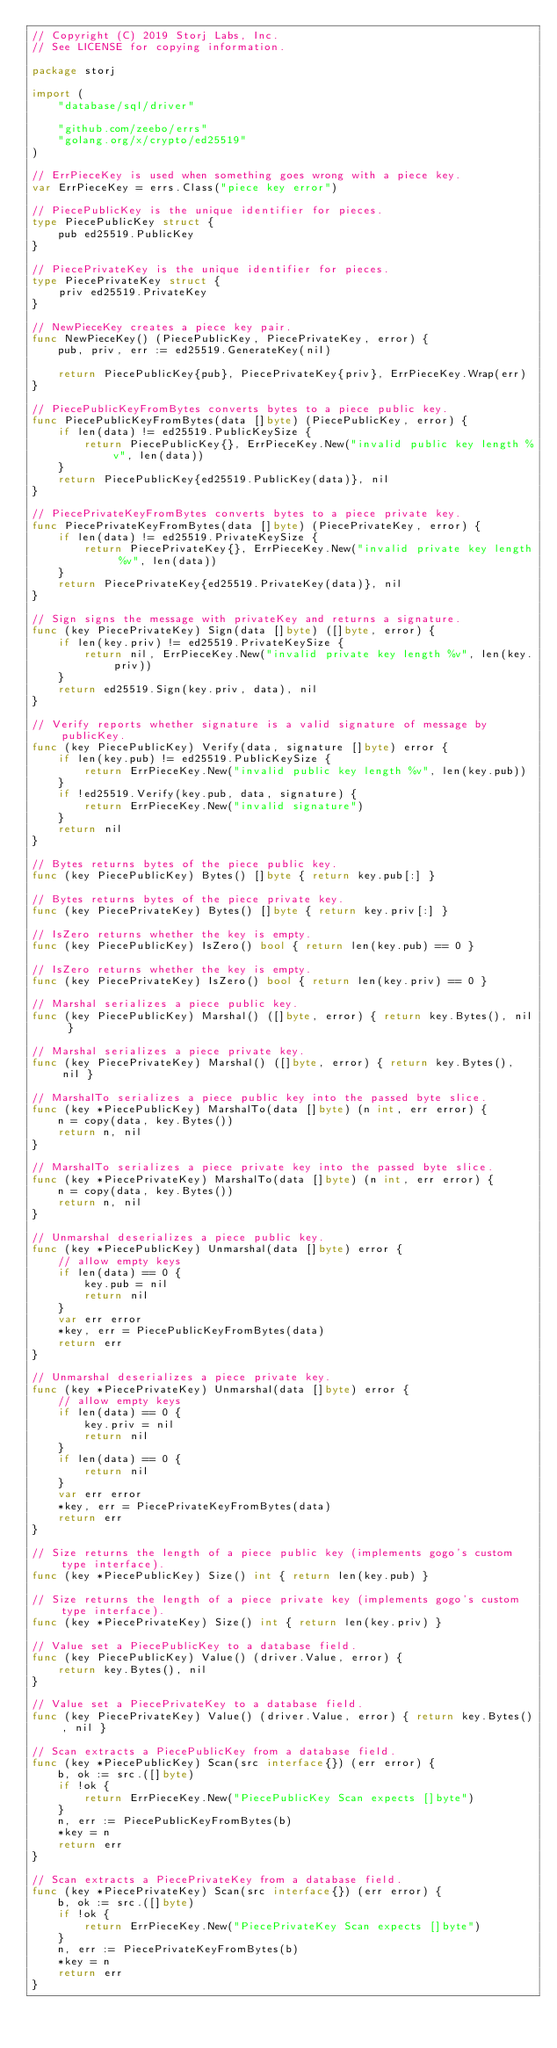Convert code to text. <code><loc_0><loc_0><loc_500><loc_500><_Go_>// Copyright (C) 2019 Storj Labs, Inc.
// See LICENSE for copying information.

package storj

import (
	"database/sql/driver"

	"github.com/zeebo/errs"
	"golang.org/x/crypto/ed25519"
)

// ErrPieceKey is used when something goes wrong with a piece key.
var ErrPieceKey = errs.Class("piece key error")

// PiecePublicKey is the unique identifier for pieces.
type PiecePublicKey struct {
	pub ed25519.PublicKey
}

// PiecePrivateKey is the unique identifier for pieces.
type PiecePrivateKey struct {
	priv ed25519.PrivateKey
}

// NewPieceKey creates a piece key pair.
func NewPieceKey() (PiecePublicKey, PiecePrivateKey, error) {
	pub, priv, err := ed25519.GenerateKey(nil)

	return PiecePublicKey{pub}, PiecePrivateKey{priv}, ErrPieceKey.Wrap(err)
}

// PiecePublicKeyFromBytes converts bytes to a piece public key.
func PiecePublicKeyFromBytes(data []byte) (PiecePublicKey, error) {
	if len(data) != ed25519.PublicKeySize {
		return PiecePublicKey{}, ErrPieceKey.New("invalid public key length %v", len(data))
	}
	return PiecePublicKey{ed25519.PublicKey(data)}, nil
}

// PiecePrivateKeyFromBytes converts bytes to a piece private key.
func PiecePrivateKeyFromBytes(data []byte) (PiecePrivateKey, error) {
	if len(data) != ed25519.PrivateKeySize {
		return PiecePrivateKey{}, ErrPieceKey.New("invalid private key length %v", len(data))
	}
	return PiecePrivateKey{ed25519.PrivateKey(data)}, nil
}

// Sign signs the message with privateKey and returns a signature.
func (key PiecePrivateKey) Sign(data []byte) ([]byte, error) {
	if len(key.priv) != ed25519.PrivateKeySize {
		return nil, ErrPieceKey.New("invalid private key length %v", len(key.priv))
	}
	return ed25519.Sign(key.priv, data), nil
}

// Verify reports whether signature is a valid signature of message by publicKey.
func (key PiecePublicKey) Verify(data, signature []byte) error {
	if len(key.pub) != ed25519.PublicKeySize {
		return ErrPieceKey.New("invalid public key length %v", len(key.pub))
	}
	if !ed25519.Verify(key.pub, data, signature) {
		return ErrPieceKey.New("invalid signature")
	}
	return nil
}

// Bytes returns bytes of the piece public key.
func (key PiecePublicKey) Bytes() []byte { return key.pub[:] }

// Bytes returns bytes of the piece private key.
func (key PiecePrivateKey) Bytes() []byte { return key.priv[:] }

// IsZero returns whether the key is empty.
func (key PiecePublicKey) IsZero() bool { return len(key.pub) == 0 }

// IsZero returns whether the key is empty.
func (key PiecePrivateKey) IsZero() bool { return len(key.priv) == 0 }

// Marshal serializes a piece public key.
func (key PiecePublicKey) Marshal() ([]byte, error) { return key.Bytes(), nil }

// Marshal serializes a piece private key.
func (key PiecePrivateKey) Marshal() ([]byte, error) { return key.Bytes(), nil }

// MarshalTo serializes a piece public key into the passed byte slice.
func (key *PiecePublicKey) MarshalTo(data []byte) (n int, err error) {
	n = copy(data, key.Bytes())
	return n, nil
}

// MarshalTo serializes a piece private key into the passed byte slice.
func (key *PiecePrivateKey) MarshalTo(data []byte) (n int, err error) {
	n = copy(data, key.Bytes())
	return n, nil
}

// Unmarshal deserializes a piece public key.
func (key *PiecePublicKey) Unmarshal(data []byte) error {
	// allow empty keys
	if len(data) == 0 {
		key.pub = nil
		return nil
	}
	var err error
	*key, err = PiecePublicKeyFromBytes(data)
	return err
}

// Unmarshal deserializes a piece private key.
func (key *PiecePrivateKey) Unmarshal(data []byte) error {
	// allow empty keys
	if len(data) == 0 {
		key.priv = nil
		return nil
	}
	if len(data) == 0 {
		return nil
	}
	var err error
	*key, err = PiecePrivateKeyFromBytes(data)
	return err
}

// Size returns the length of a piece public key (implements gogo's custom type interface).
func (key *PiecePublicKey) Size() int { return len(key.pub) }

// Size returns the length of a piece private key (implements gogo's custom type interface).
func (key *PiecePrivateKey) Size() int { return len(key.priv) }

// Value set a PiecePublicKey to a database field.
func (key PiecePublicKey) Value() (driver.Value, error) {
	return key.Bytes(), nil
}

// Value set a PiecePrivateKey to a database field.
func (key PiecePrivateKey) Value() (driver.Value, error) { return key.Bytes(), nil }

// Scan extracts a PiecePublicKey from a database field.
func (key *PiecePublicKey) Scan(src interface{}) (err error) {
	b, ok := src.([]byte)
	if !ok {
		return ErrPieceKey.New("PiecePublicKey Scan expects []byte")
	}
	n, err := PiecePublicKeyFromBytes(b)
	*key = n
	return err
}

// Scan extracts a PiecePrivateKey from a database field.
func (key *PiecePrivateKey) Scan(src interface{}) (err error) {
	b, ok := src.([]byte)
	if !ok {
		return ErrPieceKey.New("PiecePrivateKey Scan expects []byte")
	}
	n, err := PiecePrivateKeyFromBytes(b)
	*key = n
	return err
}
</code> 